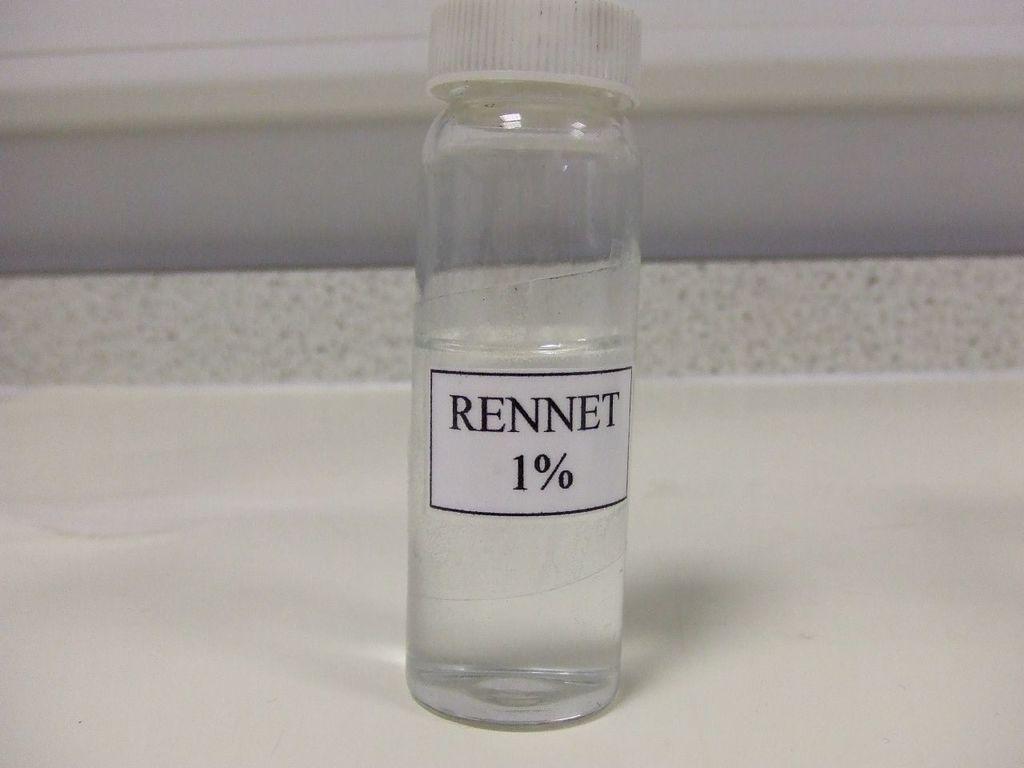What percentage is the substance in the bottle?
Ensure brevity in your answer.  1%. What does the bottle contain?
Give a very brief answer. Rennet 1%. 